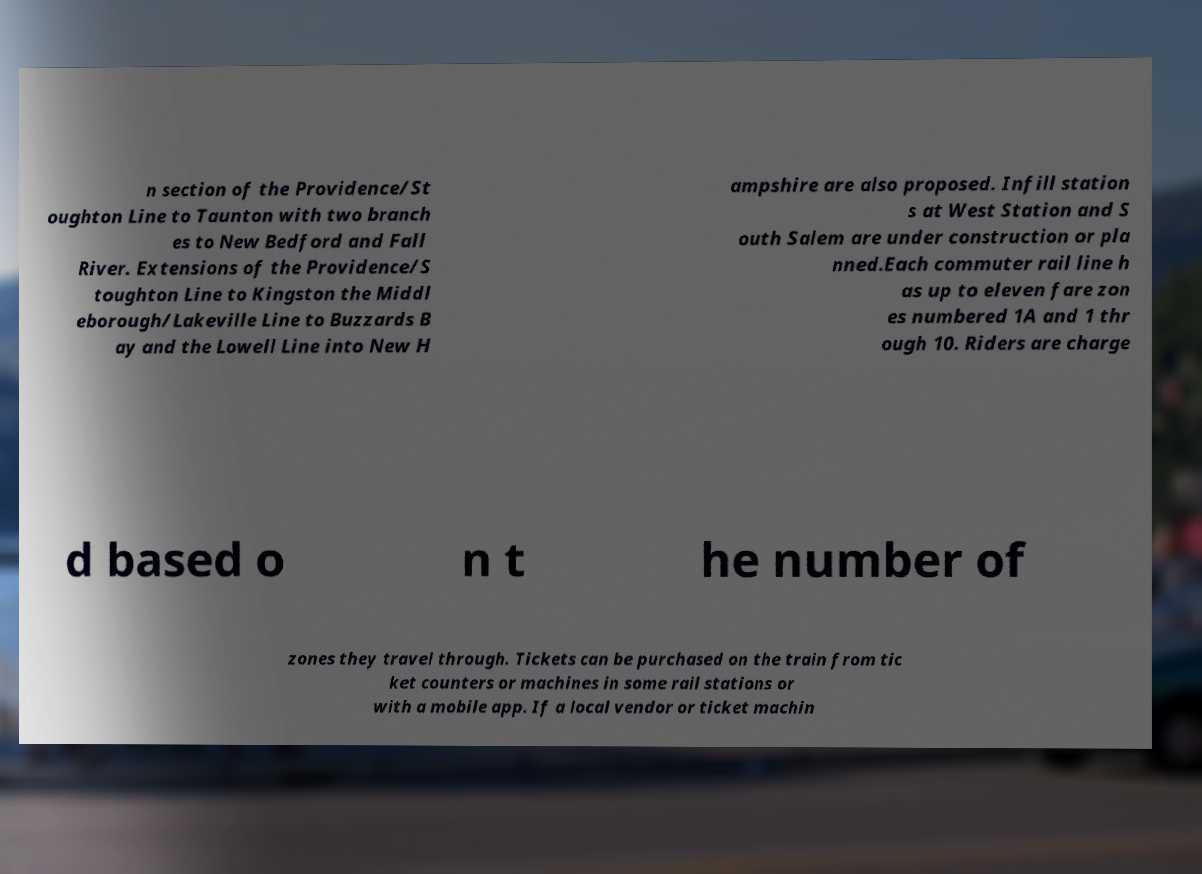Can you read and provide the text displayed in the image?This photo seems to have some interesting text. Can you extract and type it out for me? n section of the Providence/St oughton Line to Taunton with two branch es to New Bedford and Fall River. Extensions of the Providence/S toughton Line to Kingston the Middl eborough/Lakeville Line to Buzzards B ay and the Lowell Line into New H ampshire are also proposed. Infill station s at West Station and S outh Salem are under construction or pla nned.Each commuter rail line h as up to eleven fare zon es numbered 1A and 1 thr ough 10. Riders are charge d based o n t he number of zones they travel through. Tickets can be purchased on the train from tic ket counters or machines in some rail stations or with a mobile app. If a local vendor or ticket machin 